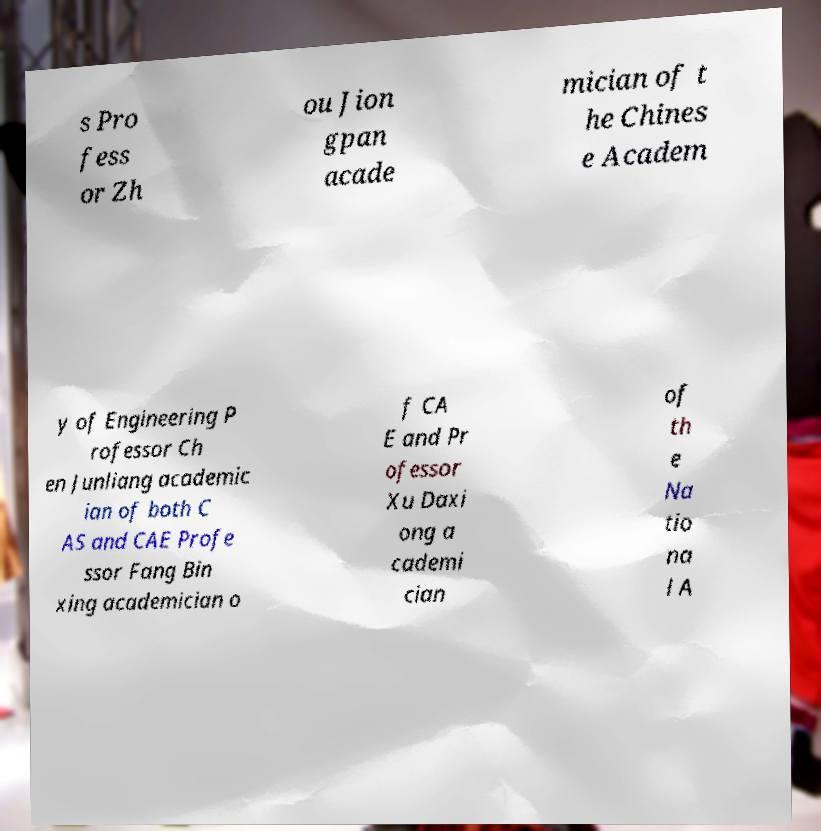Can you accurately transcribe the text from the provided image for me? s Pro fess or Zh ou Jion gpan acade mician of t he Chines e Academ y of Engineering P rofessor Ch en Junliang academic ian of both C AS and CAE Profe ssor Fang Bin xing academician o f CA E and Pr ofessor Xu Daxi ong a cademi cian of th e Na tio na l A 